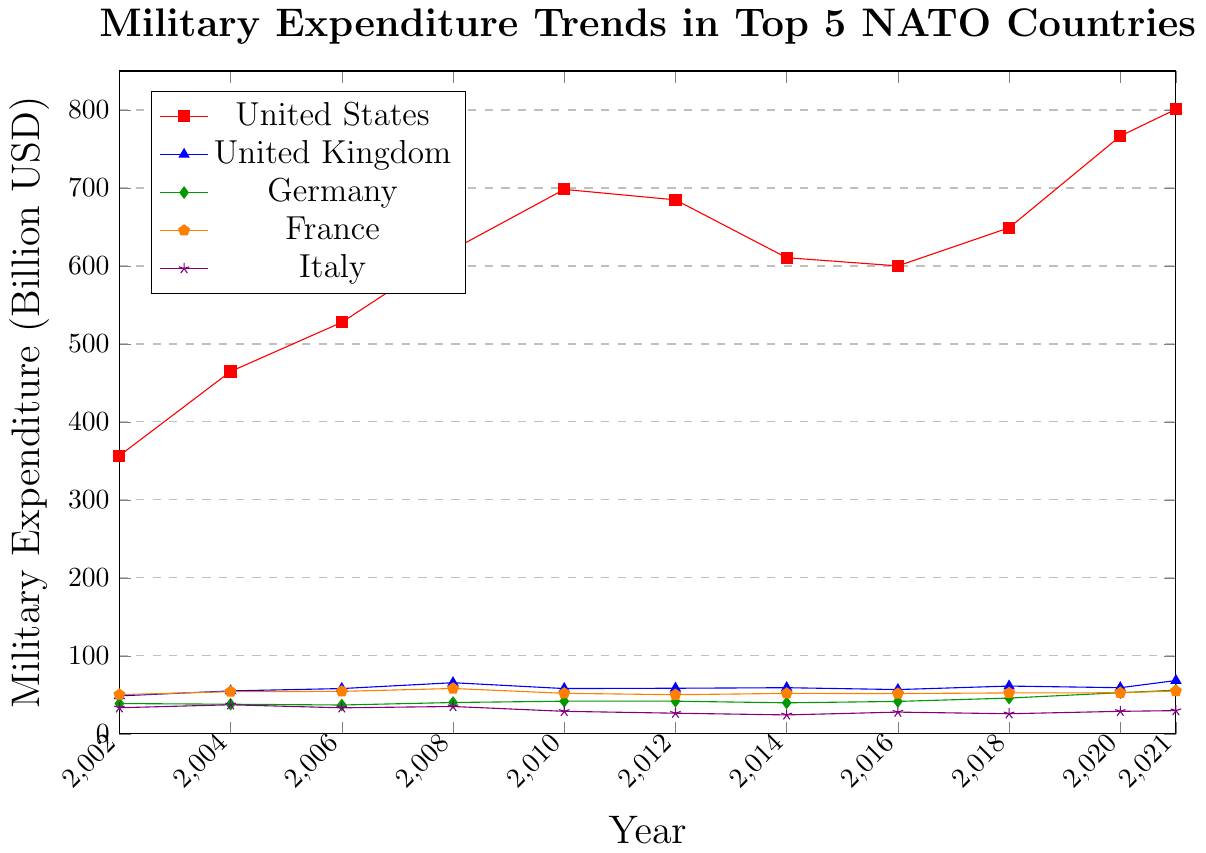What is the highest military expenditure recorded by the United States in the past 20 years? To answer this, we need to identify the highest point on the line representing the United States on the graph. It shows that the highest value is at the year 2021.
Answer: 801.0 billion USD How did Germany's military expenditure change from 2002 to 2021? Look at the value for Germany in 2002 (38.9 billion USD) and compare it with the value in 2021 (56.0 billion USD). Calculate the difference: 56.0 - 38.9 = 17.1 billion USD. Germany's military expenditure increased by 17.1 billion USD over this period.
Answer: Increased by 17.1 billion USD Which of the NATO countries had the lowest military expenditure in 2012? Examine the values for each country in the year 2012. The lowest value is Italy with 26.5 billion USD.
Answer: Italy Between which two consecutive years did the United Kingdom see the largest increase in military expenditure? Observe the trend of the United Kingdom's military expenditure from year to year. The largest increase is between 2020 (59.2 billion USD) and 2021 (68.4 billion USD). The difference is 68.4 - 59.2 = 9.2 billion USD.
Answer: Between 2020 and 2021 What is the trend of France's military expenditure between 2008 and 2012? Identify the values for France in 2008 (58.2 billion USD) and 2012 (50.2 billion USD). Note that the expenditure decreases over this period: 58.2 - 50.2 = 8 billion USD, showing a downward trend.
Answer: Downward What is the average military expenditure of Italy from 2002 to 2021? Sum up the expenditures for Italy from 2002 to 2021: 33.5 + 37.3 + 33.4 + 35.1 + 28.9 + 26.5 + 24.3 + 27.9 + 25.8 + 28.9 + 29.8 = 331.2 billion USD. Calculate the average: 331.2 / 11 = 30.11 billion USD.
Answer: 30.11 billion USD Which country had the smallest change in military expenditure from 2004 to 2006? Compare the differences in military expenditure for each country between 2004 and 2006: United States (527.7 - 464.7 = 63), United Kingdom (58.1 - 55.1 = 3), Germany (37.0 - 38.0 = -1), France (54.5 - 54.1 = 0.4), Italy (33.4 - 37.3 = -3.9). Germany had the smallest change with a 1 billion USD decrease.
Answer: Germany Which country had a steady trend in military expenditure during the 2010-2014 period? Observe the graph for each country's trend from 2010 to 2014. France shows a relatively steady trend with very small fluctuations in military expenditure.
Answer: France How many countries had an increasing trend in military expenditure from 2018 to 2021? Analyze the graph and identify countries with increasing trends from 2018 to 2021: United States, United Kingdom, Germany, and France. Italy shows a minor increase but mostly remains steady. 4 countries show a clear increasing trend.
Answer: 4 